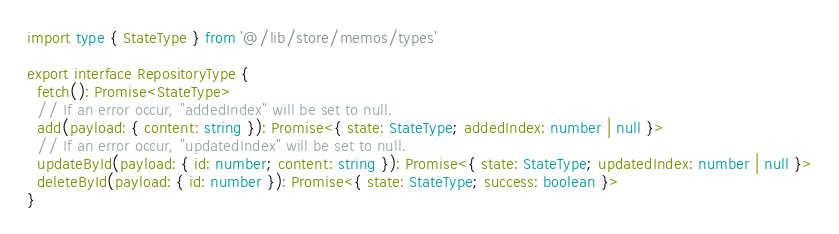Convert code to text. <code><loc_0><loc_0><loc_500><loc_500><_TypeScript_>import type { StateType } from '@/lib/store/memos/types'

export interface RepositoryType {
  fetch(): Promise<StateType>
  // If an error occur, "addedIndex" will be set to null.
  add(payload: { content: string }): Promise<{ state: StateType; addedIndex: number | null }>
  // If an error occur, "updatedIndex" will be set to null.
  updateById(payload: { id: number; content: string }): Promise<{ state: StateType; updatedIndex: number | null }>
  deleteById(payload: { id: number }): Promise<{ state: StateType; success: boolean }>
}
</code> 